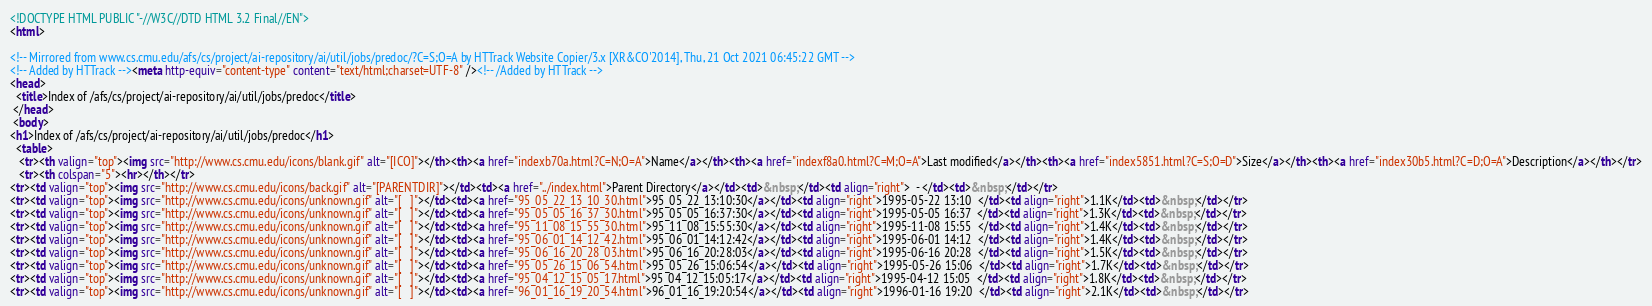<code> <loc_0><loc_0><loc_500><loc_500><_HTML_><!DOCTYPE HTML PUBLIC "-//W3C//DTD HTML 3.2 Final//EN">
<html>
 
<!-- Mirrored from www.cs.cmu.edu/afs/cs/project/ai-repository/ai/util/jobs/predoc/?C=S;O=A by HTTrack Website Copier/3.x [XR&CO'2014], Thu, 21 Oct 2021 06:45:22 GMT -->
<!-- Added by HTTrack --><meta http-equiv="content-type" content="text/html;charset=UTF-8" /><!-- /Added by HTTrack -->
<head>
  <title>Index of /afs/cs/project/ai-repository/ai/util/jobs/predoc</title>
 </head>
 <body>
<h1>Index of /afs/cs/project/ai-repository/ai/util/jobs/predoc</h1>
  <table>
   <tr><th valign="top"><img src="http://www.cs.cmu.edu/icons/blank.gif" alt="[ICO]"></th><th><a href="indexb70a.html?C=N;O=A">Name</a></th><th><a href="indexf8a0.html?C=M;O=A">Last modified</a></th><th><a href="index5851.html?C=S;O=D">Size</a></th><th><a href="index30b5.html?C=D;O=A">Description</a></th></tr>
   <tr><th colspan="5"><hr></th></tr>
<tr><td valign="top"><img src="http://www.cs.cmu.edu/icons/back.gif" alt="[PARENTDIR]"></td><td><a href="../index.html">Parent Directory</a></td><td>&nbsp;</td><td align="right">  - </td><td>&nbsp;</td></tr>
<tr><td valign="top"><img src="http://www.cs.cmu.edu/icons/unknown.gif" alt="[   ]"></td><td><a href="95_05_22_13_10_30.html">95_05_22_13:10:30</a></td><td align="right">1995-05-22 13:10  </td><td align="right">1.1K</td><td>&nbsp;</td></tr>
<tr><td valign="top"><img src="http://www.cs.cmu.edu/icons/unknown.gif" alt="[   ]"></td><td><a href="95_05_05_16_37_30.html">95_05_05_16:37:30</a></td><td align="right">1995-05-05 16:37  </td><td align="right">1.3K</td><td>&nbsp;</td></tr>
<tr><td valign="top"><img src="http://www.cs.cmu.edu/icons/unknown.gif" alt="[   ]"></td><td><a href="95_11_08_15_55_30.html">95_11_08_15:55:30</a></td><td align="right">1995-11-08 15:55  </td><td align="right">1.4K</td><td>&nbsp;</td></tr>
<tr><td valign="top"><img src="http://www.cs.cmu.edu/icons/unknown.gif" alt="[   ]"></td><td><a href="95_06_01_14_12_42.html">95_06_01_14:12:42</a></td><td align="right">1995-06-01 14:12  </td><td align="right">1.4K</td><td>&nbsp;</td></tr>
<tr><td valign="top"><img src="http://www.cs.cmu.edu/icons/unknown.gif" alt="[   ]"></td><td><a href="95_06_16_20_28_03.html">95_06_16_20:28:03</a></td><td align="right">1995-06-16 20:28  </td><td align="right">1.5K</td><td>&nbsp;</td></tr>
<tr><td valign="top"><img src="http://www.cs.cmu.edu/icons/unknown.gif" alt="[   ]"></td><td><a href="95_05_26_15_06_54.html">95_05_26_15:06:54</a></td><td align="right">1995-05-26 15:06  </td><td align="right">1.7K</td><td>&nbsp;</td></tr>
<tr><td valign="top"><img src="http://www.cs.cmu.edu/icons/unknown.gif" alt="[   ]"></td><td><a href="95_04_12_15_05_17.html">95_04_12_15:05:17</a></td><td align="right">1995-04-12 15:05  </td><td align="right">1.8K</td><td>&nbsp;</td></tr>
<tr><td valign="top"><img src="http://www.cs.cmu.edu/icons/unknown.gif" alt="[   ]"></td><td><a href="96_01_16_19_20_54.html">96_01_16_19:20:54</a></td><td align="right">1996-01-16 19:20  </td><td align="right">2.1K</td><td>&nbsp;</td></tr></code> 